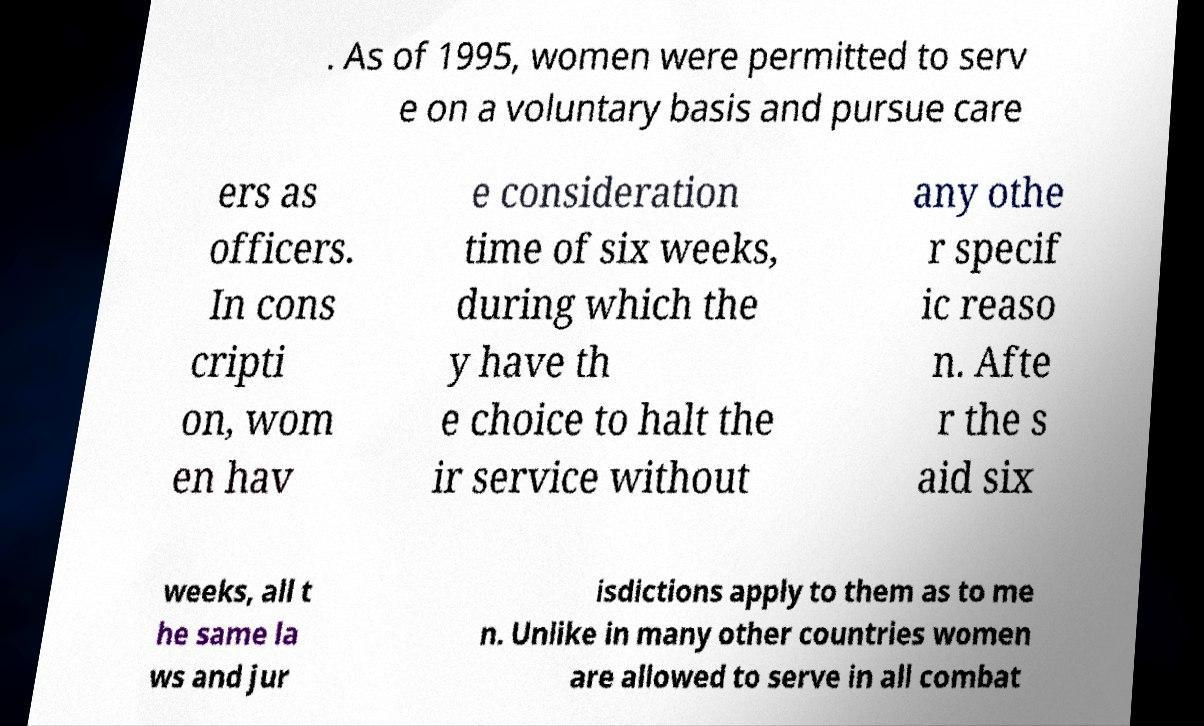Could you assist in decoding the text presented in this image and type it out clearly? . As of 1995, women were permitted to serv e on a voluntary basis and pursue care ers as officers. In cons cripti on, wom en hav e consideration time of six weeks, during which the y have th e choice to halt the ir service without any othe r specif ic reaso n. Afte r the s aid six weeks, all t he same la ws and jur isdictions apply to them as to me n. Unlike in many other countries women are allowed to serve in all combat 